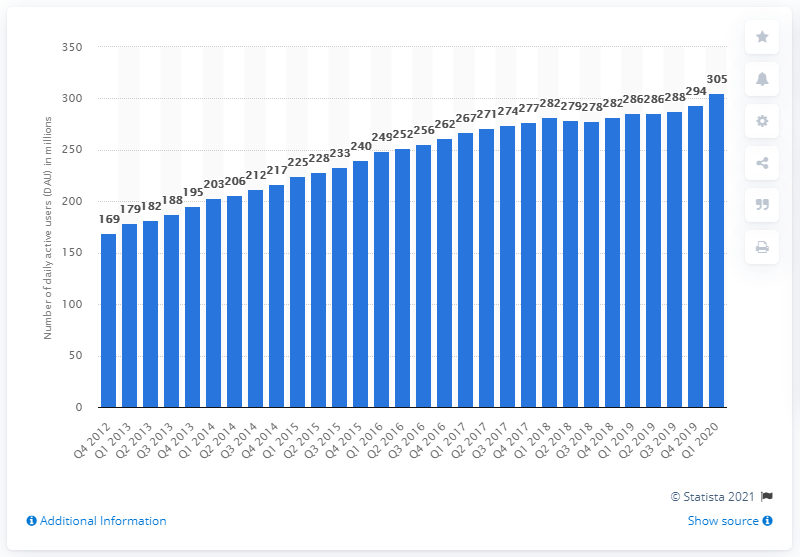Mention a couple of crucial points in this snapshot. In the second quarter of 2019, an estimated 305 million people in Europe used Facebook on a daily basis. In the second quarter of 2019, an estimated 288 million people in Europe used Facebook on a daily basis. 